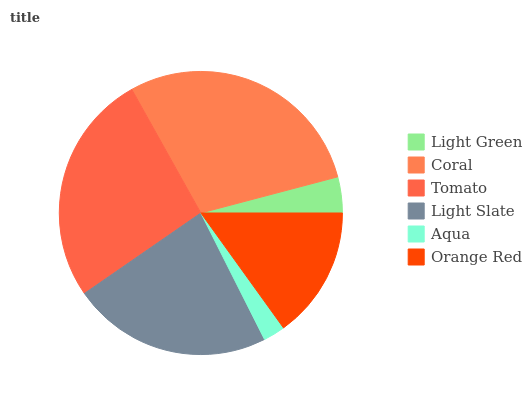Is Aqua the minimum?
Answer yes or no. Yes. Is Coral the maximum?
Answer yes or no. Yes. Is Tomato the minimum?
Answer yes or no. No. Is Tomato the maximum?
Answer yes or no. No. Is Coral greater than Tomato?
Answer yes or no. Yes. Is Tomato less than Coral?
Answer yes or no. Yes. Is Tomato greater than Coral?
Answer yes or no. No. Is Coral less than Tomato?
Answer yes or no. No. Is Light Slate the high median?
Answer yes or no. Yes. Is Orange Red the low median?
Answer yes or no. Yes. Is Orange Red the high median?
Answer yes or no. No. Is Aqua the low median?
Answer yes or no. No. 